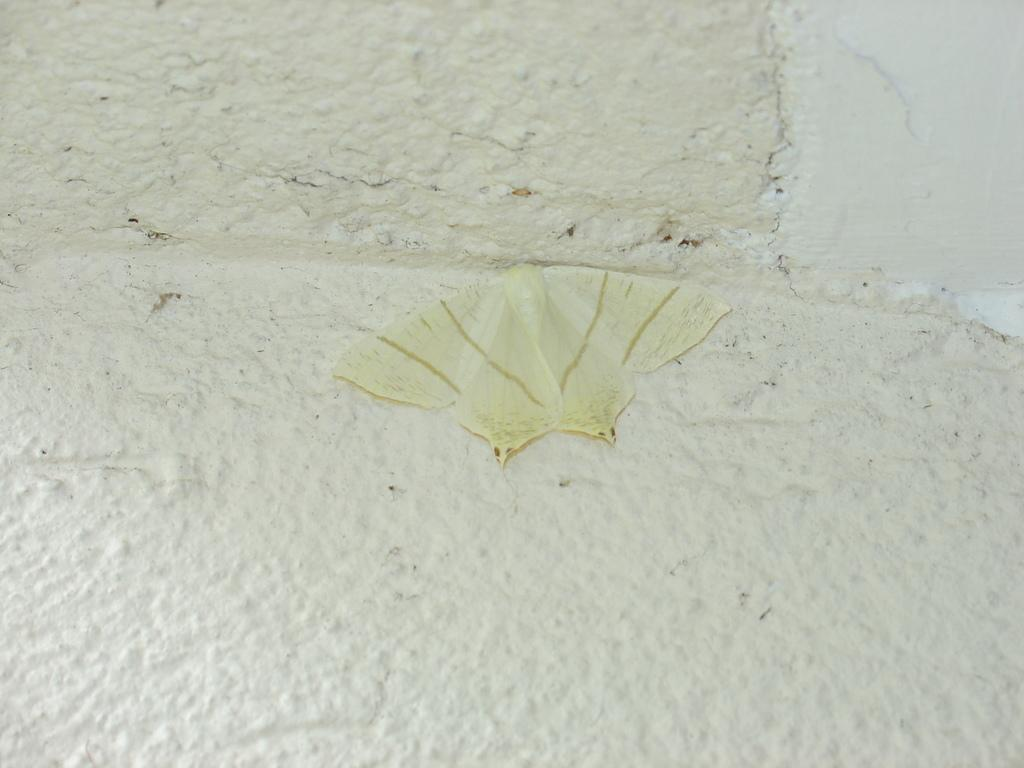What type of creature can be seen in the image? There is an insect in the image. What is the background or surface that the insect is on? The insect is on a white surface. Is the pin used to hold the insect in place in the image? There is no pin present in the image, and the insect is not being held in place by any object. 